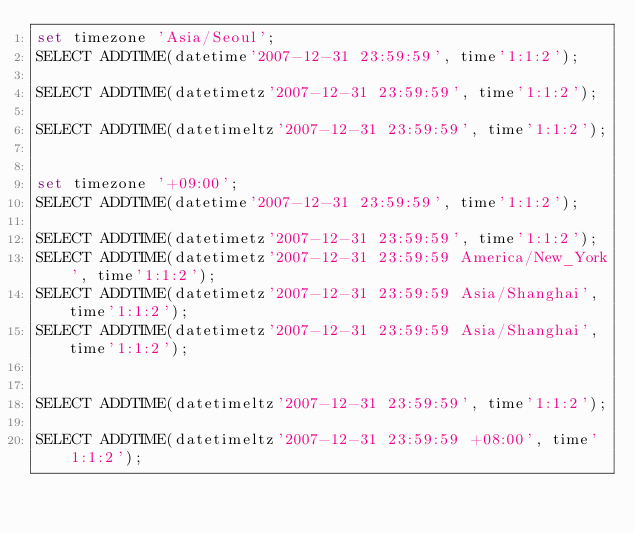<code> <loc_0><loc_0><loc_500><loc_500><_SQL_>set timezone 'Asia/Seoul';
SELECT ADDTIME(datetime'2007-12-31 23:59:59', time'1:1:2');

SELECT ADDTIME(datetimetz'2007-12-31 23:59:59', time'1:1:2');

SELECT ADDTIME(datetimeltz'2007-12-31 23:59:59', time'1:1:2');


set timezone '+09:00';
SELECT ADDTIME(datetime'2007-12-31 23:59:59', time'1:1:2');

SELECT ADDTIME(datetimetz'2007-12-31 23:59:59', time'1:1:2');
SELECT ADDTIME(datetimetz'2007-12-31 23:59:59 America/New_York', time'1:1:2');
SELECT ADDTIME(datetimetz'2007-12-31 23:59:59 Asia/Shanghai', time'1:1:2');
SELECT ADDTIME(datetimetz'2007-12-31 23:59:59 Asia/Shanghai', time'1:1:2');


SELECT ADDTIME(datetimeltz'2007-12-31 23:59:59', time'1:1:2');

SELECT ADDTIME(datetimeltz'2007-12-31 23:59:59 +08:00', time'1:1:2');


</code> 